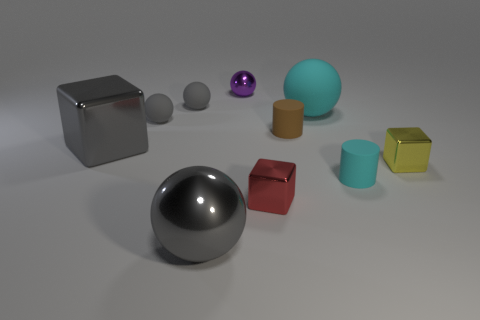Subtract all blue blocks. How many gray balls are left? 3 Subtract all purple shiny spheres. How many spheres are left? 4 Subtract all blue balls. Subtract all yellow blocks. How many balls are left? 5 Subtract all cylinders. How many objects are left? 8 Add 1 cyan matte cylinders. How many cyan matte cylinders are left? 2 Add 8 large gray balls. How many large gray balls exist? 9 Subtract 0 green cylinders. How many objects are left? 10 Subtract all big gray cubes. Subtract all gray cubes. How many objects are left? 8 